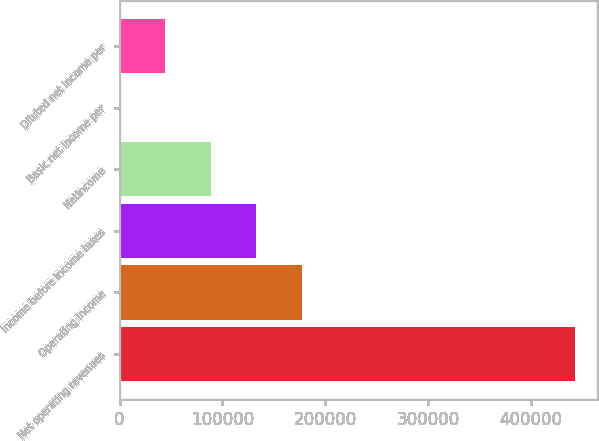Convert chart to OTSL. <chart><loc_0><loc_0><loc_500><loc_500><bar_chart><fcel>Net operating revenues<fcel>Operating income<fcel>Income before income taxes<fcel>Netincome<fcel>Basic net income per<fcel>Diluted net income per<nl><fcel>442677<fcel>177071<fcel>132803<fcel>88535.5<fcel>0.1<fcel>44267.8<nl></chart> 